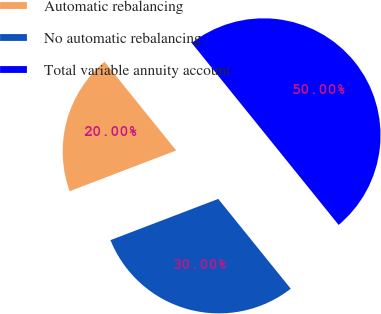Convert chart. <chart><loc_0><loc_0><loc_500><loc_500><pie_chart><fcel>Automatic rebalancing<fcel>No automatic rebalancing<fcel>Total variable annuity account<nl><fcel>20.0%<fcel>30.0%<fcel>50.0%<nl></chart> 